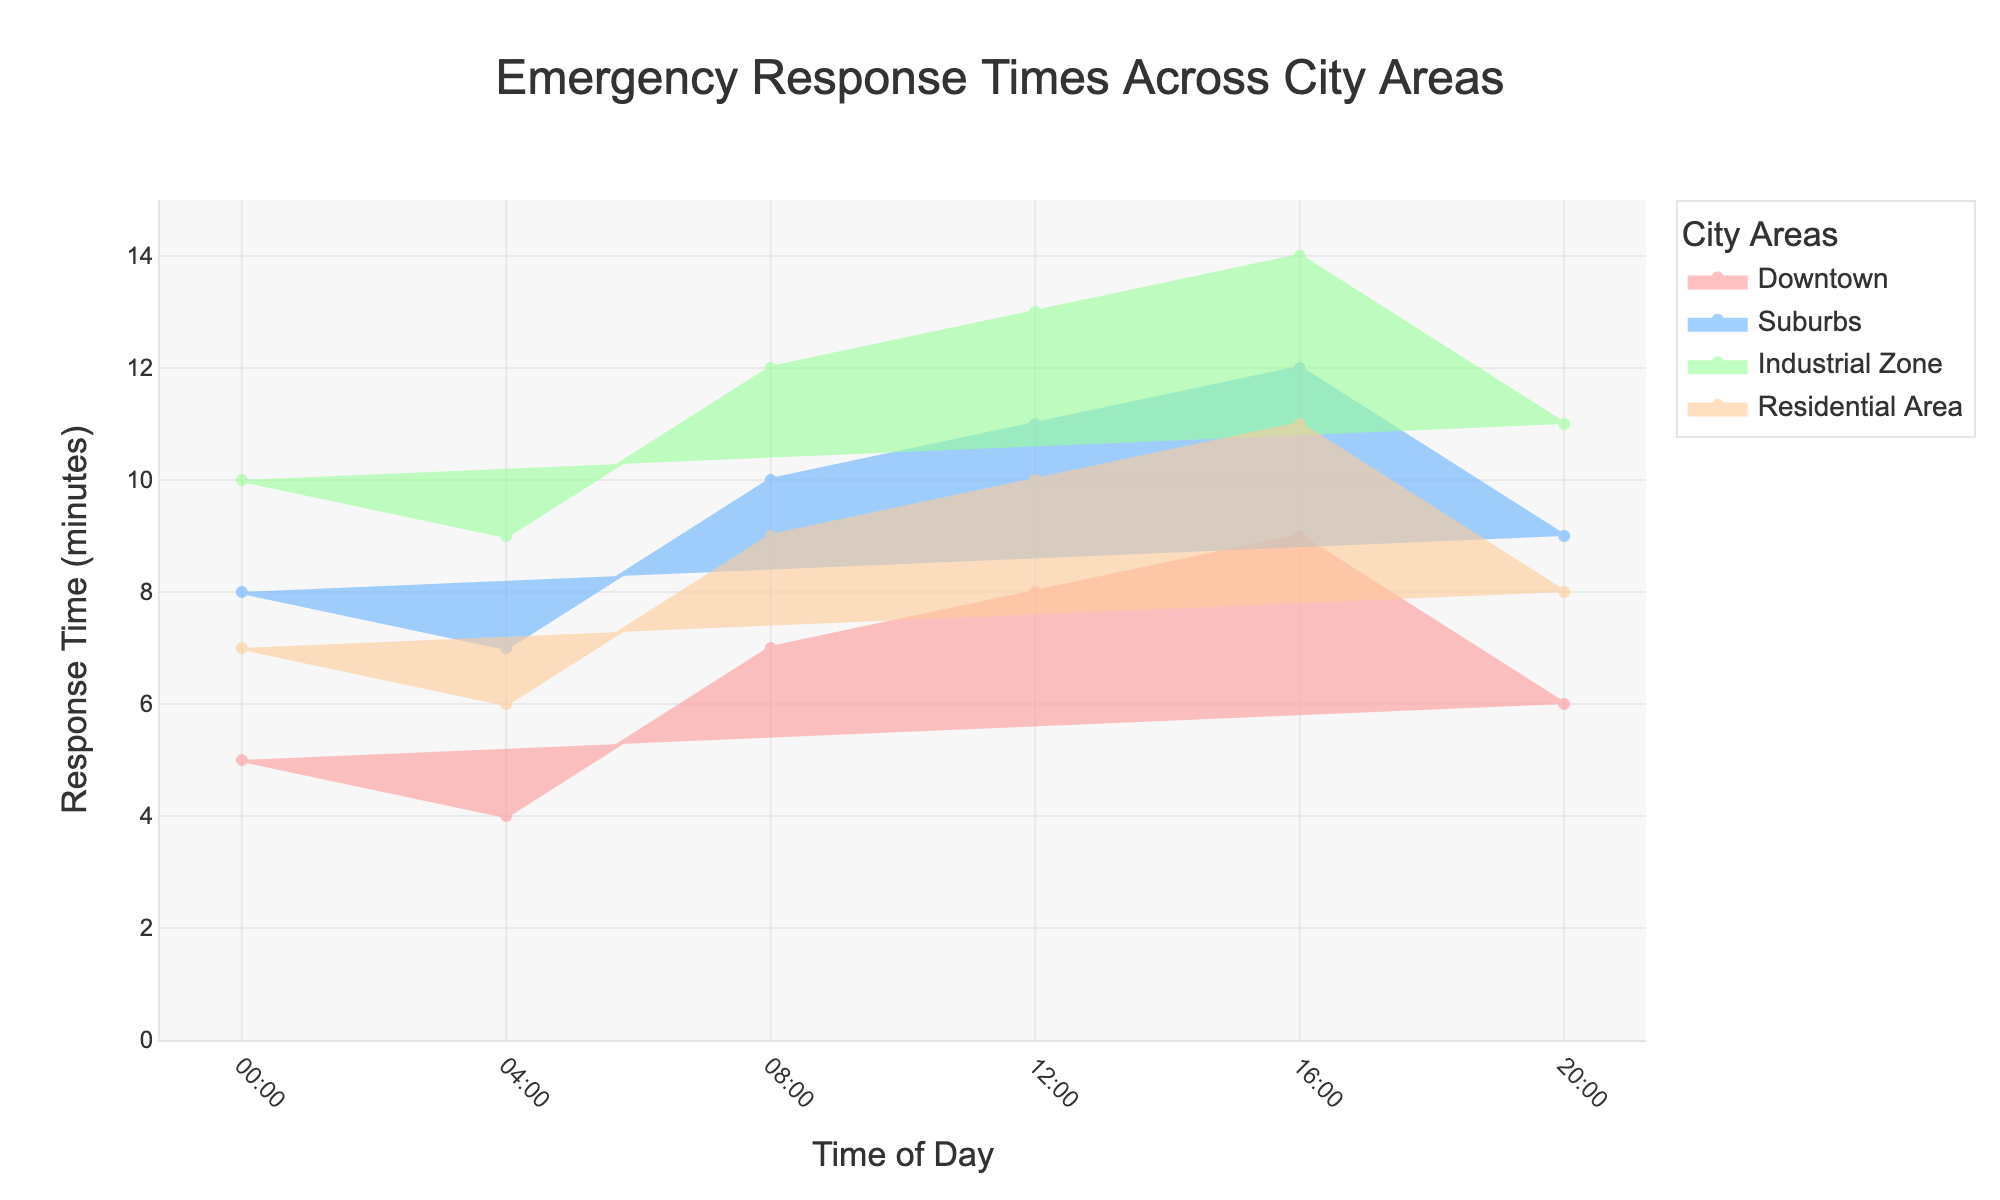How many areas are represented in the figure? There are different colored areas, each representing a different part of the city. Counting them in the legend shows four city areas.
Answer: Four What is the response time in the Downtown area at 12:00? Look for the Downtown trace on the chart and check the response time at 12:00 on the x-axis. The response time is given as 8 minutes.
Answer: 8 minutes Which area has the highest response time at 20:00? Examine the traces at 20:00 and compare their values. Industrial Zone has the highest value at 11 minutes.
Answer: Industrial Zone What is the average response time in the Industrial Zone over a day? Add the response times for the Industrial Zone (10+9+12+13+14+11) and divide by the number of times (6). The average is (10+9+12+13+14+11)/6 = 69/6 = 11.5 minutes.
Answer: 11.5 minutes At what time is the response time equal in both Downtown and Residential Area? Check where the traces for Downtown and Residential Area are at the same height on the y-axis. They are equal at 00:00 and 20:00, both at 6 minutes.
Answer: 00:00 and 20:00 By how many minutes does the response time in the Suburbs decrease from 08:00 to 20:00? Look at the Suburbs trace at 08:00 and 20:00. The response time decreases from 10 minutes to 9 minutes respectively. The difference is 10 - 9.
Answer: 1 minute Which area shows the most variation in response times throughout the day? Compare the range of response times for each area from the plotted lines. The Industrial Zone varies from 9 to 14 minutes, showing the highest variation.
Answer: Industrial Zone Is the response time in the Residential Area ever higher than in the Suburbs? Compare the Residential Area and Suburbs traces. The response time in the Residential Area never exceeds that of the Suburbs.
Answer: No During which time period does the Suburbs have its highest response time? Check the Suburbs trace for peaks across different times. The highest value is at 16:00, at 12 minutes.
Answer: 16:00 What is the difference in response time between Industrial Zone and Residential Area at 04:00? Locate the response times for both areas at 04:00 and subtract Residential Area (6 minutes) from Industrial Zone (9 minutes). The difference is 9 - 6.
Answer: 3 minutes 